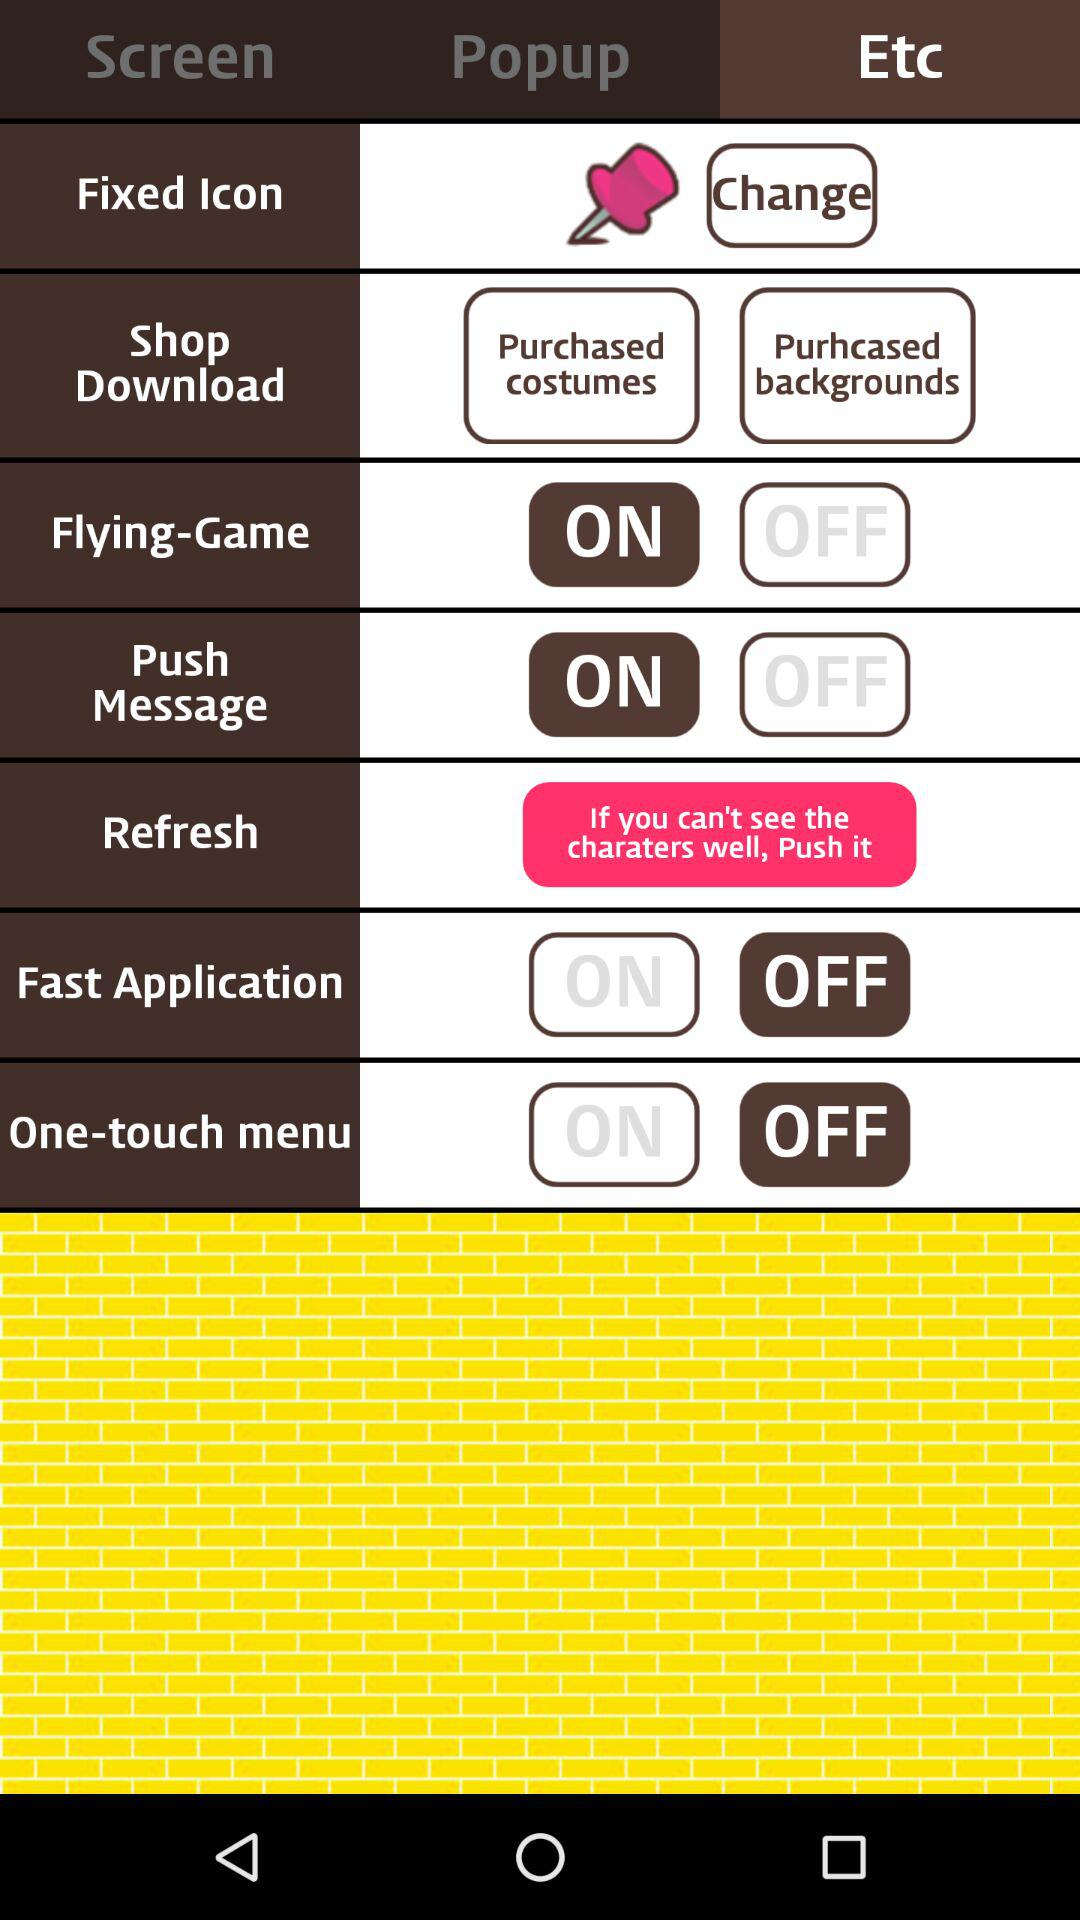What is the status of "Push Message"? The status of "Push Message" is "on". 